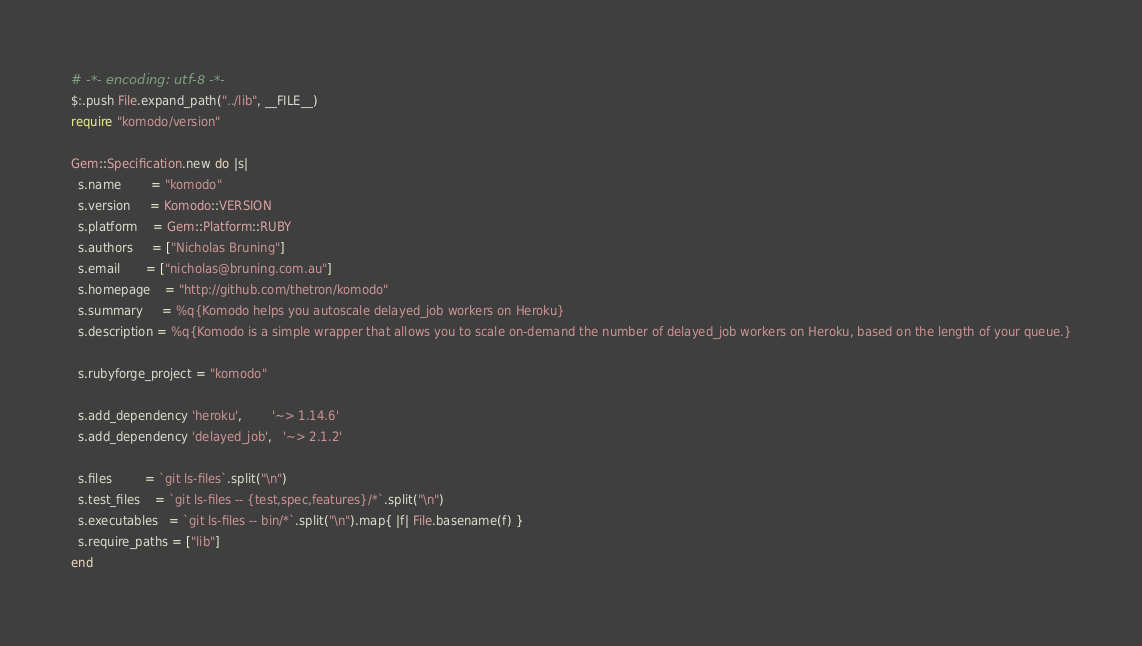Convert code to text. <code><loc_0><loc_0><loc_500><loc_500><_Ruby_># -*- encoding: utf-8 -*-
$:.push File.expand_path("../lib", __FILE__)
require "komodo/version"

Gem::Specification.new do |s|
  s.name        = "komodo"
  s.version     = Komodo::VERSION
  s.platform    = Gem::Platform::RUBY
  s.authors     = ["Nicholas Bruning"]
  s.email       = ["nicholas@bruning.com.au"]
  s.homepage    = "http://github.com/thetron/komodo"
  s.summary     = %q{Komodo helps you autoscale delayed_job workers on Heroku}
  s.description = %q{Komodo is a simple wrapper that allows you to scale on-demand the number of delayed_job workers on Heroku, based on the length of your queue.}

  s.rubyforge_project = "komodo"
  
  s.add_dependency 'heroku',        '~> 1.14.6'
  s.add_dependency 'delayed_job',   '~> 2.1.2'

  s.files         = `git ls-files`.split("\n")
  s.test_files    = `git ls-files -- {test,spec,features}/*`.split("\n")
  s.executables   = `git ls-files -- bin/*`.split("\n").map{ |f| File.basename(f) }
  s.require_paths = ["lib"]
end
</code> 